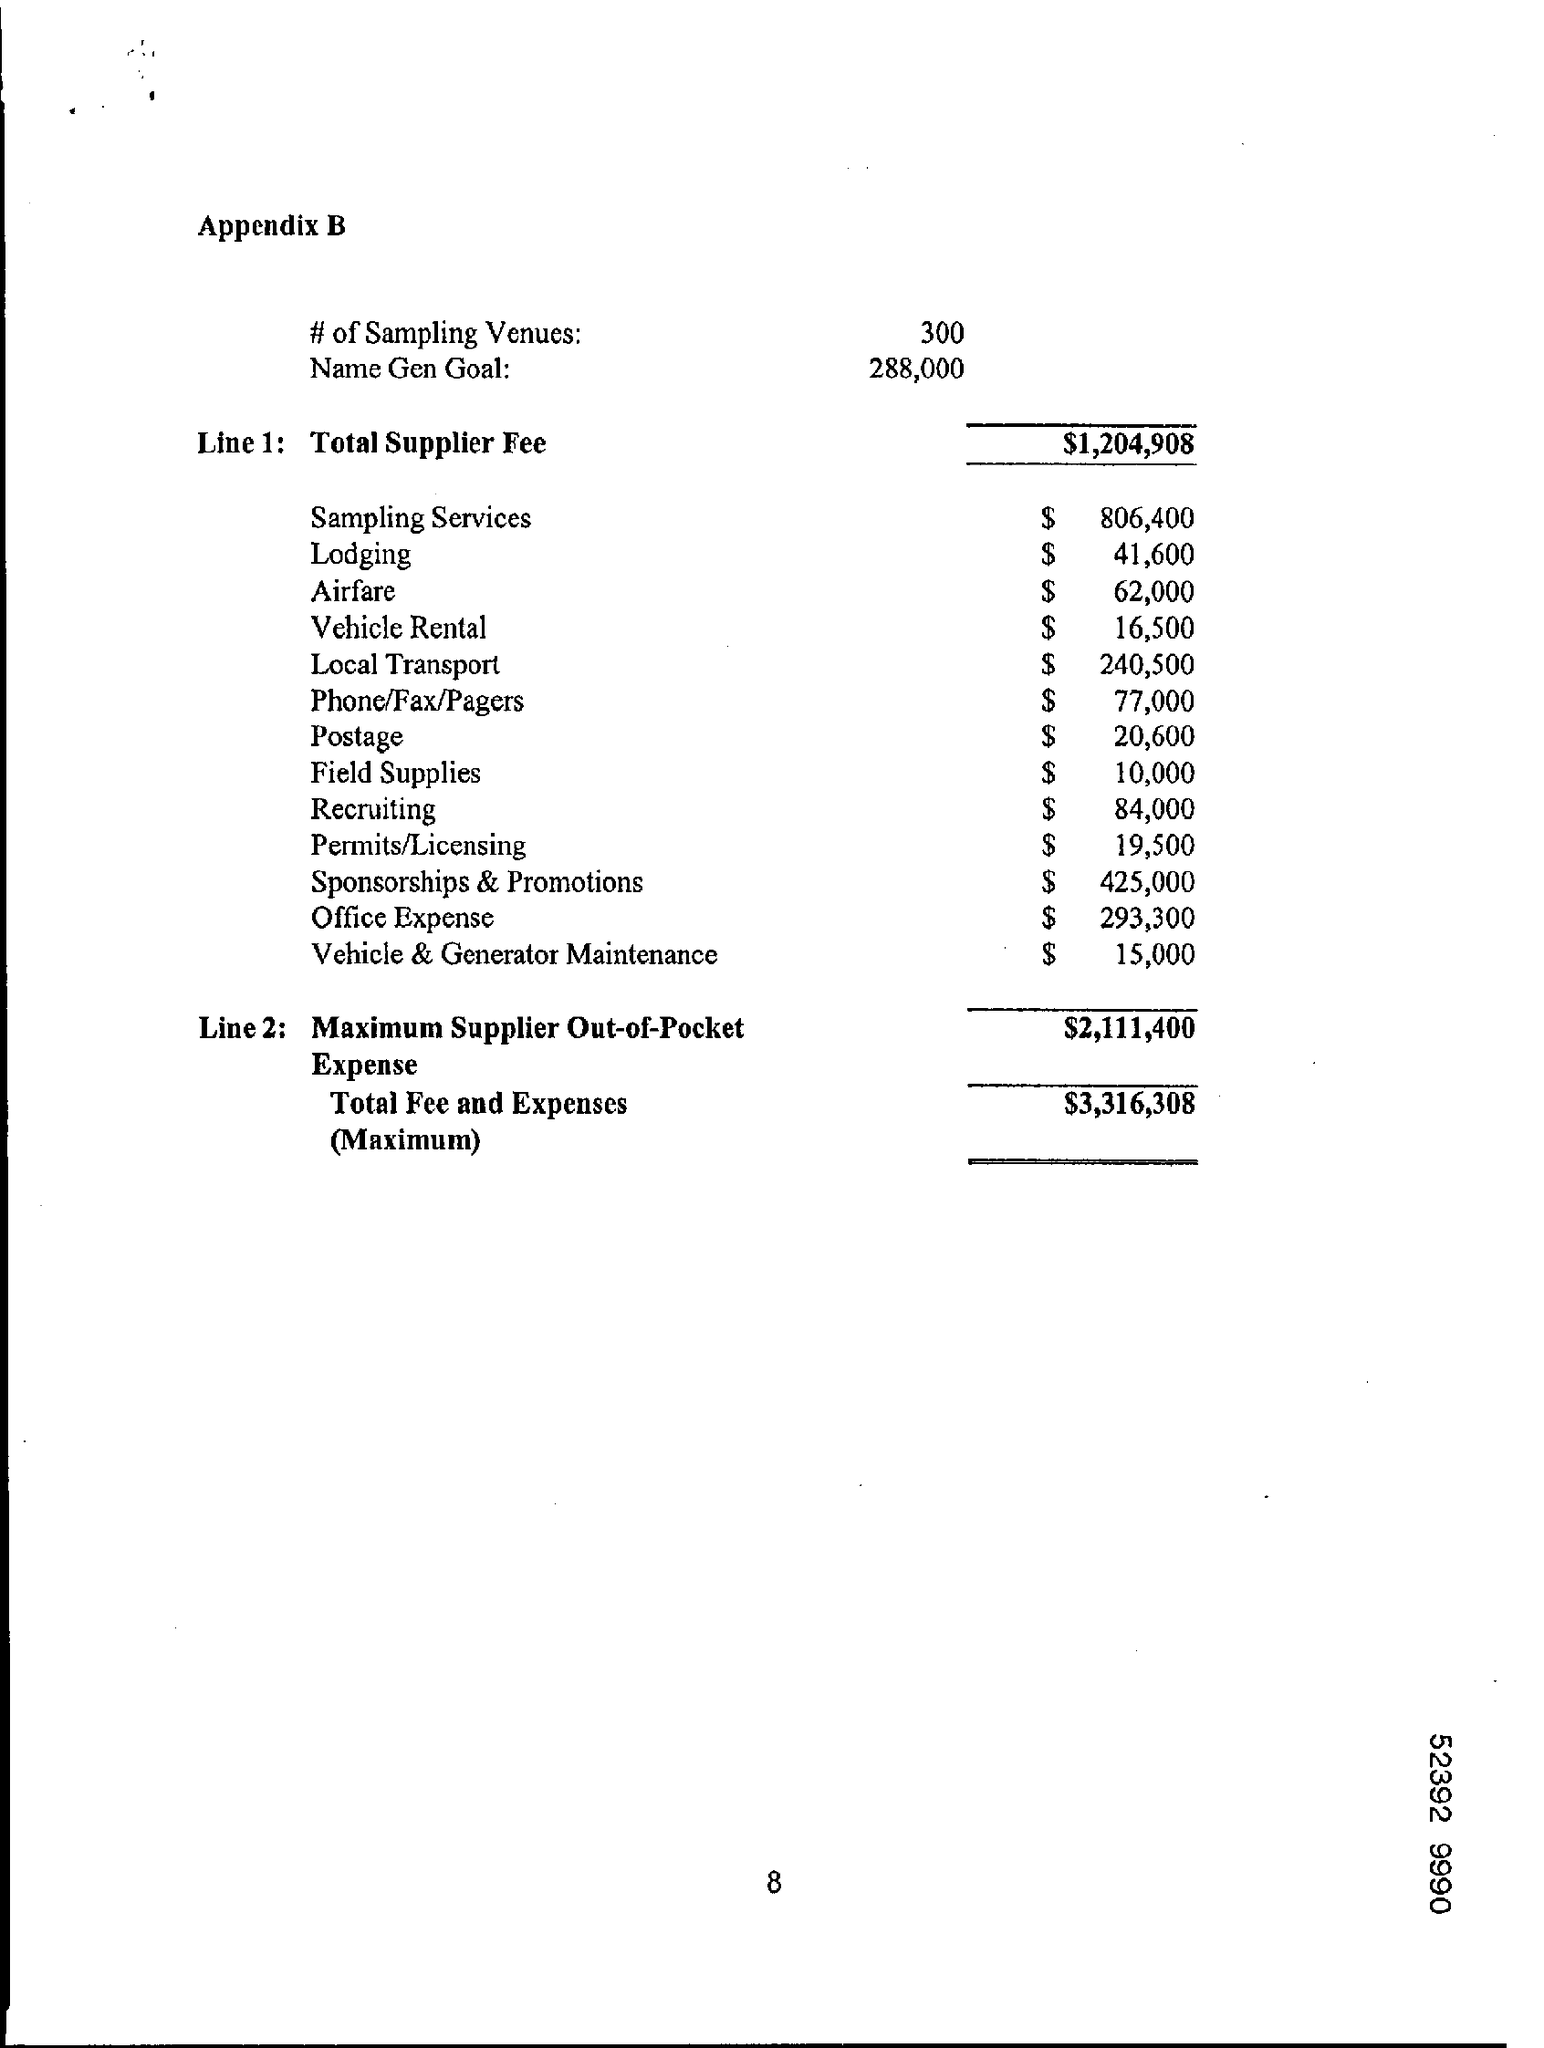Give some essential details in this illustration. The appendix mentioned in the document is B.. The total fees and expenses are expected to be $3,316,308. The document lists 300 sampling venues. The total supplier fees amount to $1,204,908. 